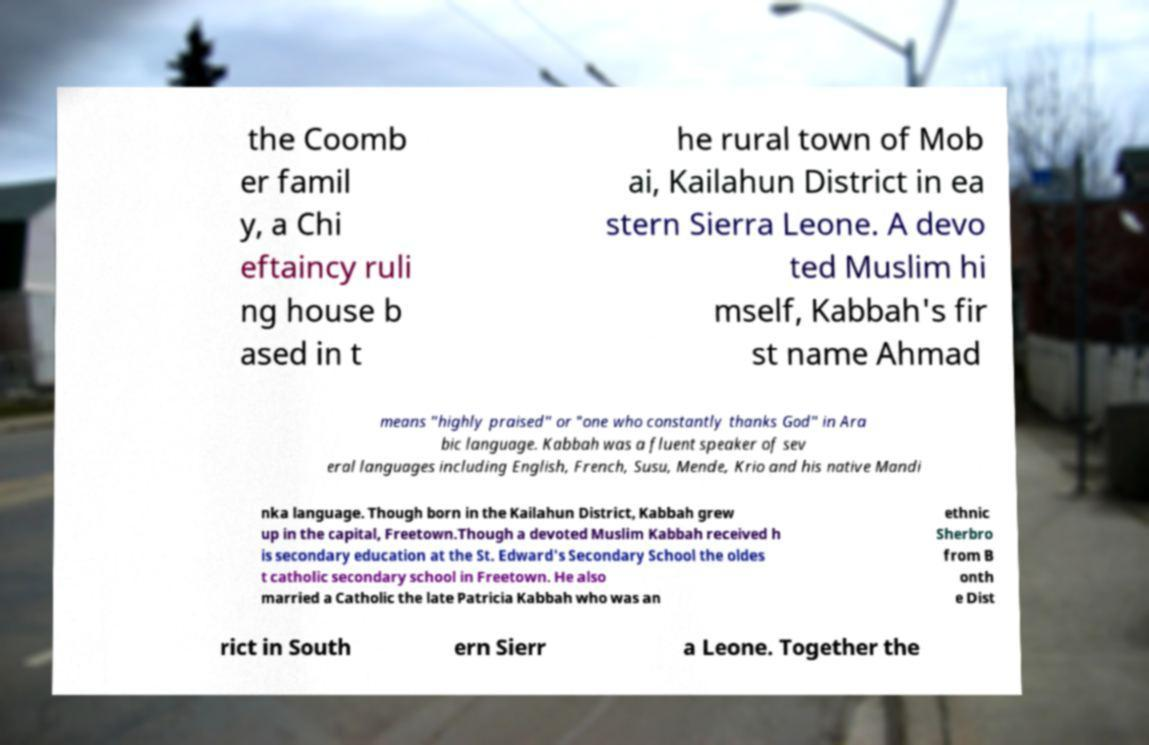For documentation purposes, I need the text within this image transcribed. Could you provide that? the Coomb er famil y, a Chi eftaincy ruli ng house b ased in t he rural town of Mob ai, Kailahun District in ea stern Sierra Leone. A devo ted Muslim hi mself, Kabbah's fir st name Ahmad means "highly praised" or "one who constantly thanks God" in Ara bic language. Kabbah was a fluent speaker of sev eral languages including English, French, Susu, Mende, Krio and his native Mandi nka language. Though born in the Kailahun District, Kabbah grew up in the capital, Freetown.Though a devoted Muslim Kabbah received h is secondary education at the St. Edward's Secondary School the oldes t catholic secondary school in Freetown. He also married a Catholic the late Patricia Kabbah who was an ethnic Sherbro from B onth e Dist rict in South ern Sierr a Leone. Together the 